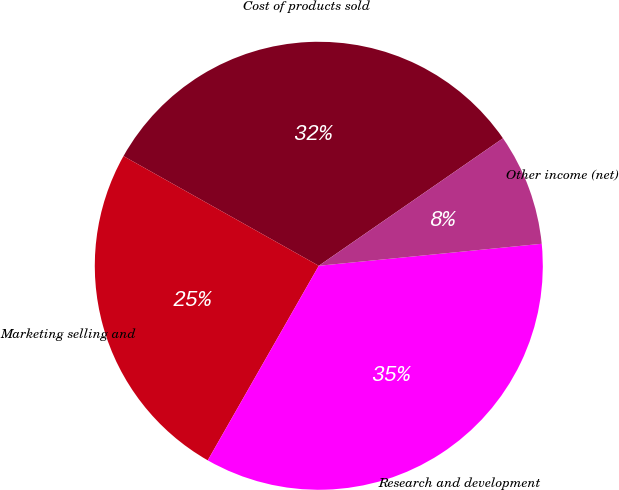Convert chart to OTSL. <chart><loc_0><loc_0><loc_500><loc_500><pie_chart><fcel>Cost of products sold<fcel>Marketing selling and<fcel>Research and development<fcel>Other income (net)<nl><fcel>32.22%<fcel>24.89%<fcel>34.82%<fcel>8.07%<nl></chart> 